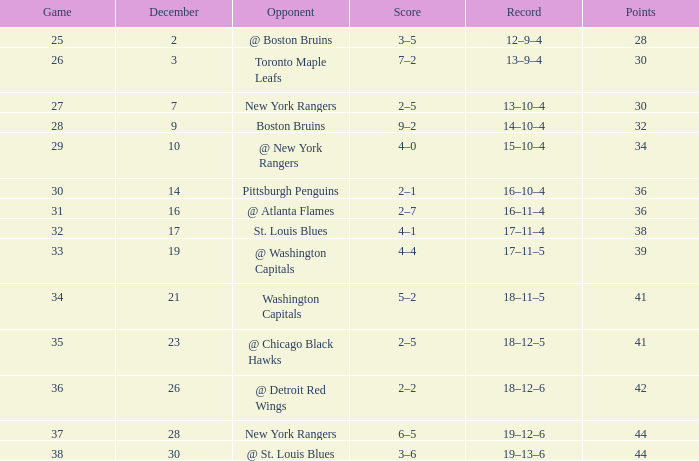In which 30-score game, do the points amount to 36? 2–1. 